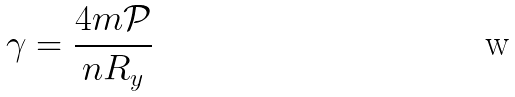<formula> <loc_0><loc_0><loc_500><loc_500>\gamma = \frac { 4 m \mathcal { P } } { n R _ { y } }</formula> 